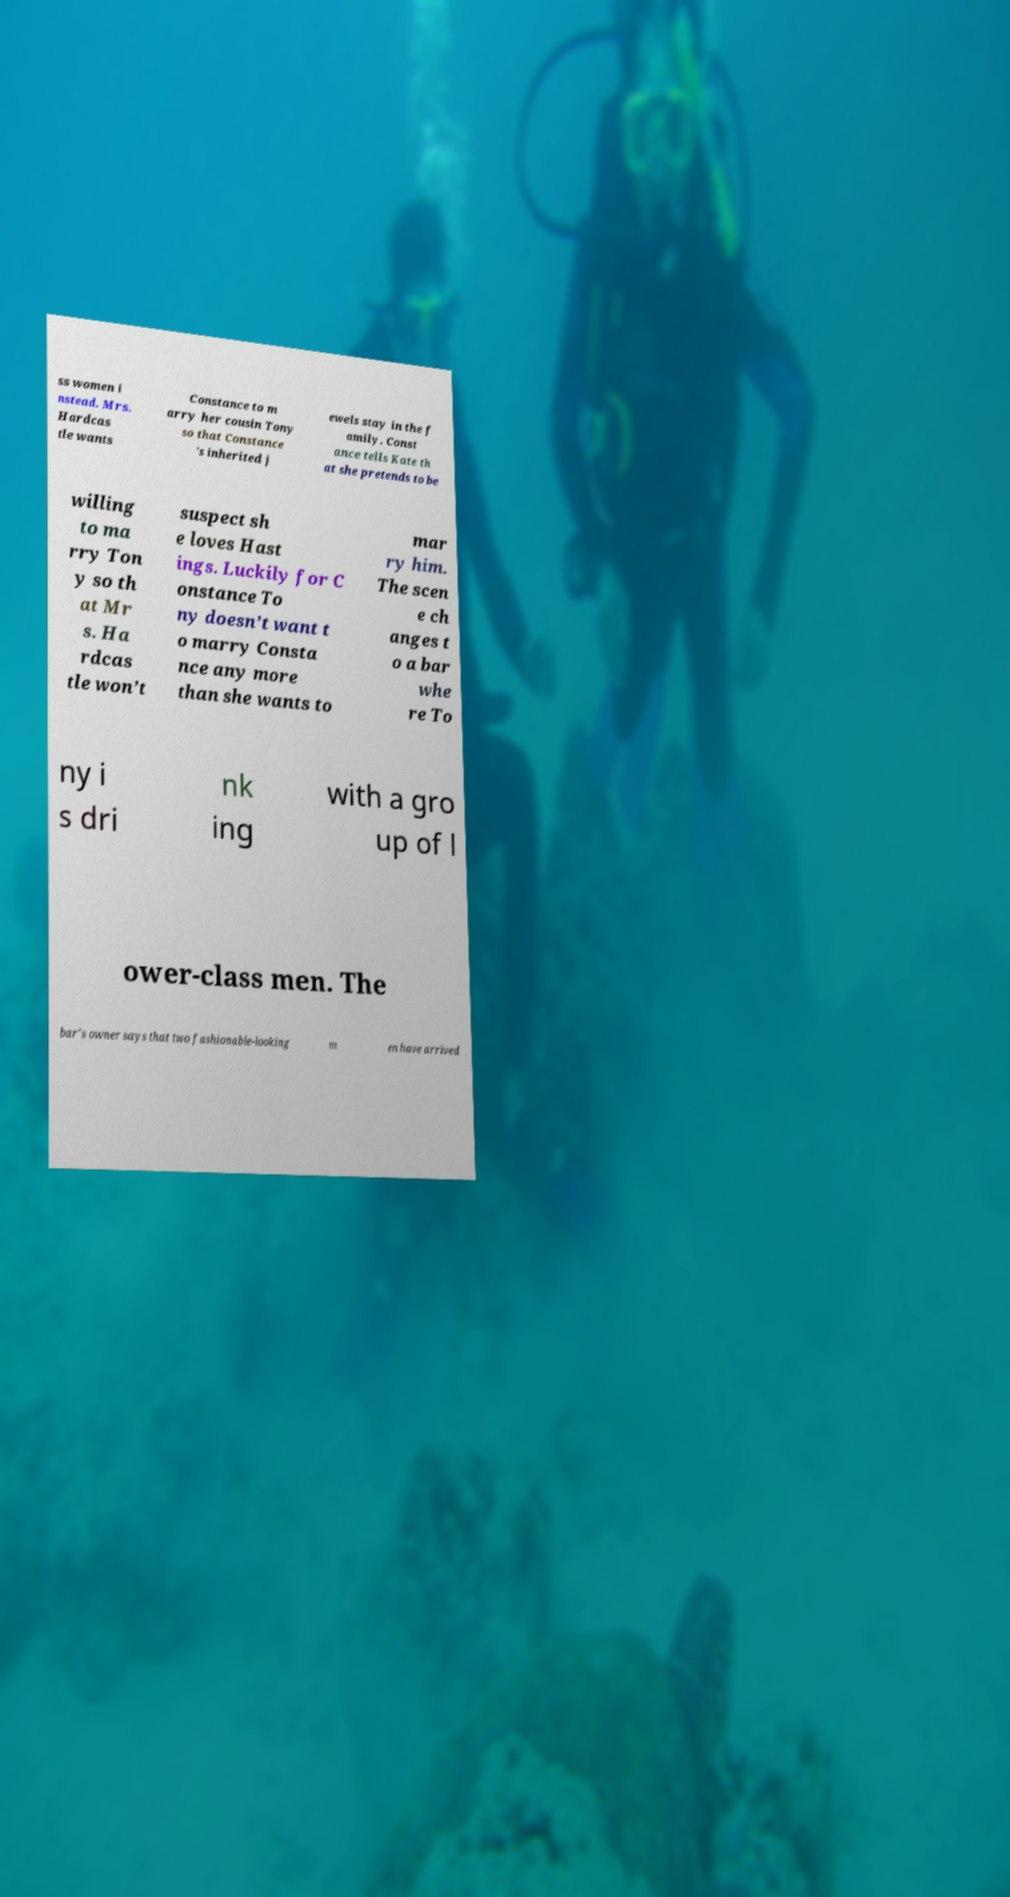Can you read and provide the text displayed in the image?This photo seems to have some interesting text. Can you extract and type it out for me? ss women i nstead. Mrs. Hardcas tle wants Constance to m arry her cousin Tony so that Constance ’s inherited j ewels stay in the f amily. Const ance tells Kate th at she pretends to be willing to ma rry Ton y so th at Mr s. Ha rdcas tle won’t suspect sh e loves Hast ings. Luckily for C onstance To ny doesn’t want t o marry Consta nce any more than she wants to mar ry him. The scen e ch anges t o a bar whe re To ny i s dri nk ing with a gro up of l ower-class men. The bar’s owner says that two fashionable-looking m en have arrived 